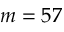Convert formula to latex. <formula><loc_0><loc_0><loc_500><loc_500>m = 5 7</formula> 